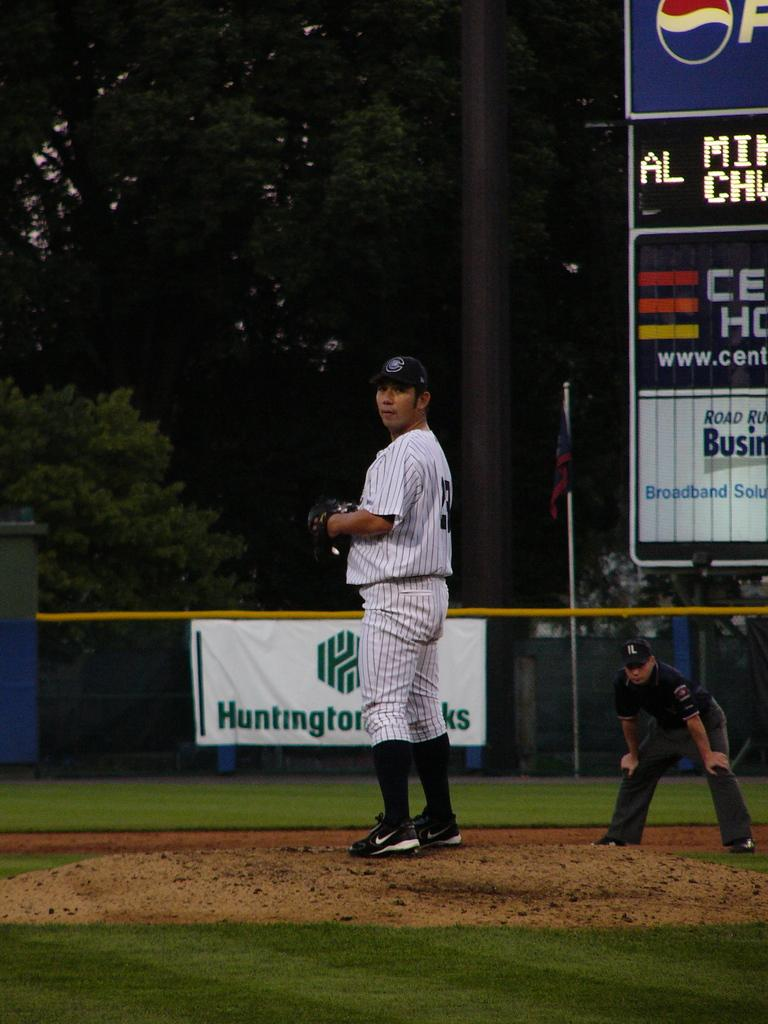<image>
Render a clear and concise summary of the photo. A sign with the word Huntington on it can be seen behind a baseball player. 